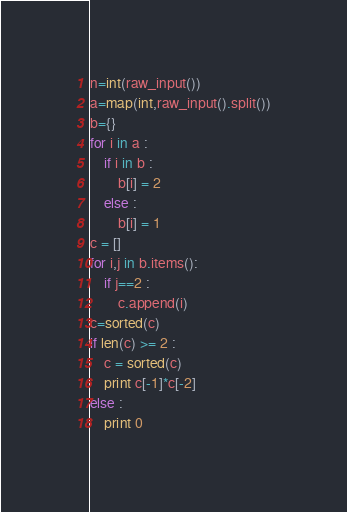<code> <loc_0><loc_0><loc_500><loc_500><_Python_>n=int(raw_input())
a=map(int,raw_input().split())
b={}
for i in a :
    if i in b :
        b[i] = 2
    else :
        b[i] = 1
c = []
for i,j in b.items():
    if j==2 :
        c.append(i)
c=sorted(c)
if len(c) >= 2 :
    c = sorted(c)
    print c[-1]*c[-2]
else :
    print 0</code> 